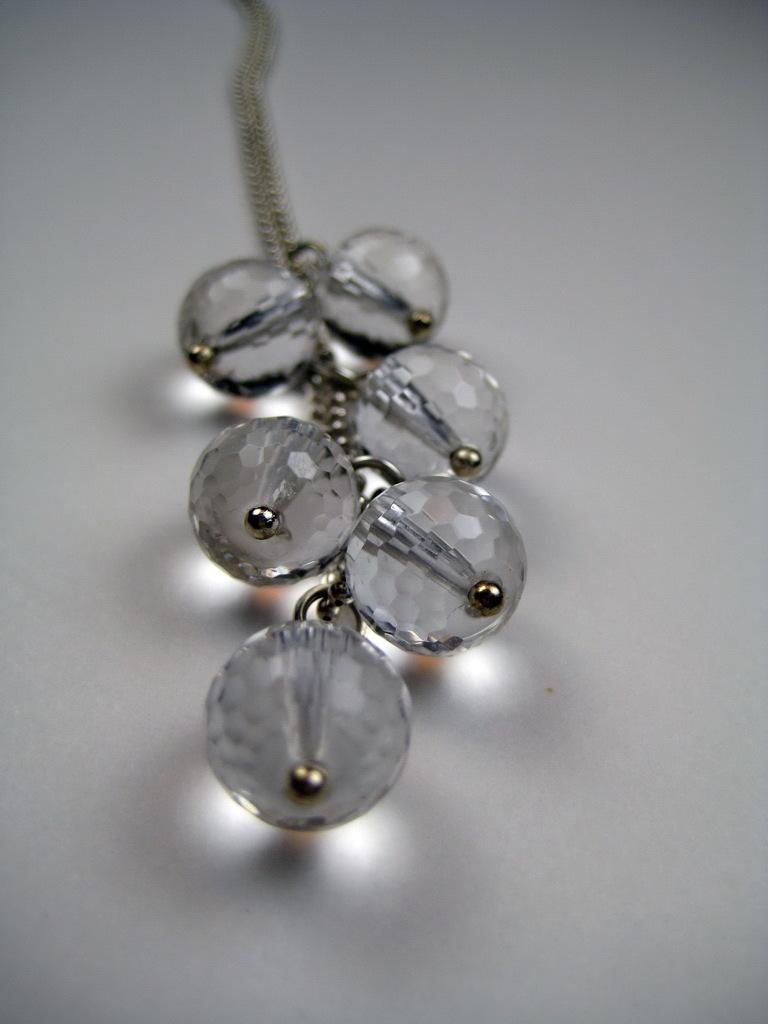What objects are connected by a chain in the image? There are stones attached to a chain in the image. What color is the background of the image? The background of the image is white. How many yams are hidden behind the stones in the image? There are no yams present in the image; it only features stones attached to a chain. 